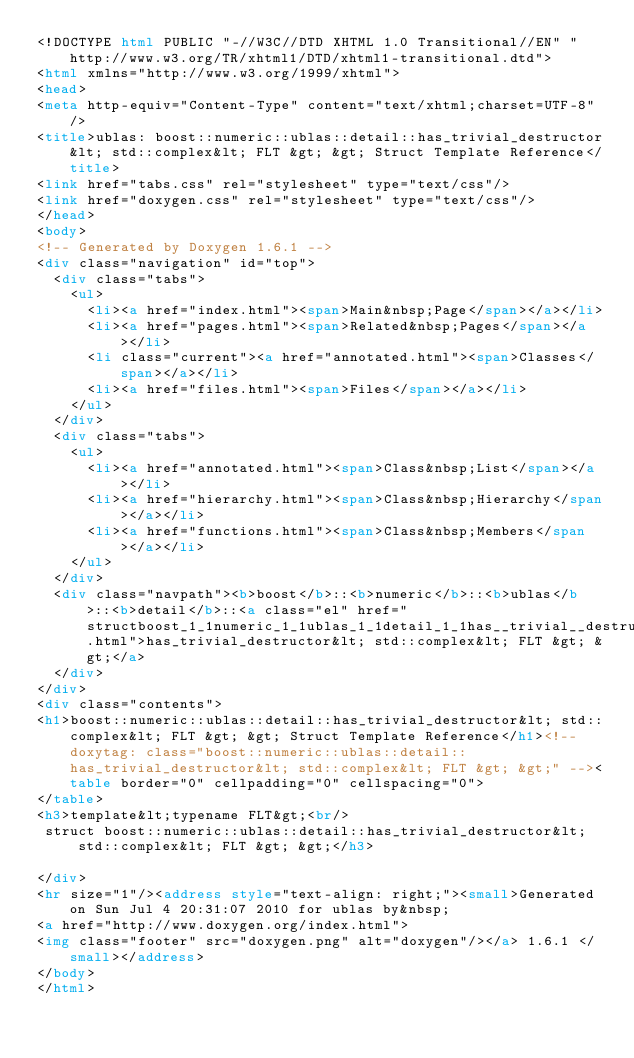Convert code to text. <code><loc_0><loc_0><loc_500><loc_500><_HTML_><!DOCTYPE html PUBLIC "-//W3C//DTD XHTML 1.0 Transitional//EN" "http://www.w3.org/TR/xhtml1/DTD/xhtml1-transitional.dtd">
<html xmlns="http://www.w3.org/1999/xhtml">
<head>
<meta http-equiv="Content-Type" content="text/xhtml;charset=UTF-8"/>
<title>ublas: boost::numeric::ublas::detail::has_trivial_destructor&lt; std::complex&lt; FLT &gt; &gt; Struct Template Reference</title>
<link href="tabs.css" rel="stylesheet" type="text/css"/>
<link href="doxygen.css" rel="stylesheet" type="text/css"/>
</head>
<body>
<!-- Generated by Doxygen 1.6.1 -->
<div class="navigation" id="top">
  <div class="tabs">
    <ul>
      <li><a href="index.html"><span>Main&nbsp;Page</span></a></li>
      <li><a href="pages.html"><span>Related&nbsp;Pages</span></a></li>
      <li class="current"><a href="annotated.html"><span>Classes</span></a></li>
      <li><a href="files.html"><span>Files</span></a></li>
    </ul>
  </div>
  <div class="tabs">
    <ul>
      <li><a href="annotated.html"><span>Class&nbsp;List</span></a></li>
      <li><a href="hierarchy.html"><span>Class&nbsp;Hierarchy</span></a></li>
      <li><a href="functions.html"><span>Class&nbsp;Members</span></a></li>
    </ul>
  </div>
  <div class="navpath"><b>boost</b>::<b>numeric</b>::<b>ublas</b>::<b>detail</b>::<a class="el" href="structboost_1_1numeric_1_1ublas_1_1detail_1_1has__trivial__destructor_3_01std_1_1complex_3_01_f_l_t_01_4_01_4.html">has_trivial_destructor&lt; std::complex&lt; FLT &gt; &gt;</a>
  </div>
</div>
<div class="contents">
<h1>boost::numeric::ublas::detail::has_trivial_destructor&lt; std::complex&lt; FLT &gt; &gt; Struct Template Reference</h1><!-- doxytag: class="boost::numeric::ublas::detail::has_trivial_destructor&lt; std::complex&lt; FLT &gt; &gt;" --><table border="0" cellpadding="0" cellspacing="0">
</table>
<h3>template&lt;typename FLT&gt;<br/>
 struct boost::numeric::ublas::detail::has_trivial_destructor&lt; std::complex&lt; FLT &gt; &gt;</h3>

</div>
<hr size="1"/><address style="text-align: right;"><small>Generated on Sun Jul 4 20:31:07 2010 for ublas by&nbsp;
<a href="http://www.doxygen.org/index.html">
<img class="footer" src="doxygen.png" alt="doxygen"/></a> 1.6.1 </small></address>
</body>
</html>
</code> 